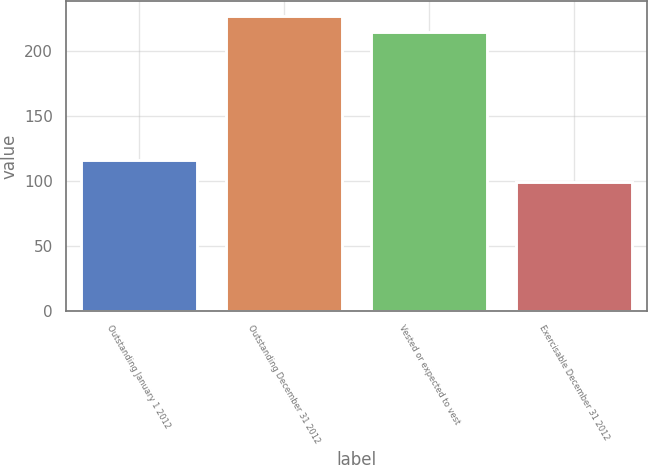Convert chart. <chart><loc_0><loc_0><loc_500><loc_500><bar_chart><fcel>Outstanding January 1 2012<fcel>Outstanding December 31 2012<fcel>Vested or expected to vest<fcel>Exercisable December 31 2012<nl><fcel>116<fcel>226.9<fcel>215<fcel>99<nl></chart> 